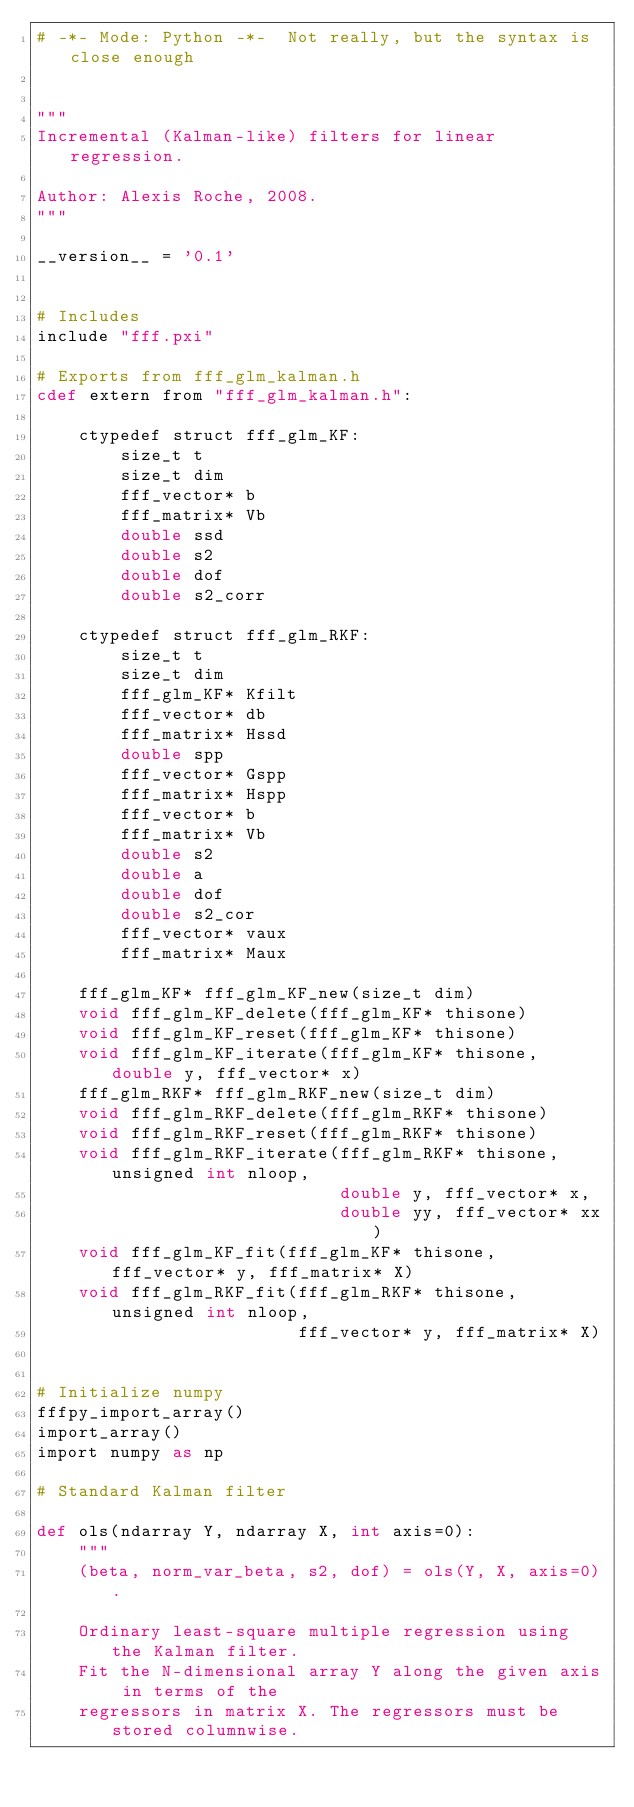Convert code to text. <code><loc_0><loc_0><loc_500><loc_500><_Cython_># -*- Mode: Python -*-  Not really, but the syntax is close enough


"""
Incremental (Kalman-like) filters for linear regression. 

Author: Alexis Roche, 2008.
"""

__version__ = '0.1'


# Includes
include "fff.pxi"

# Exports from fff_glm_kalman.h
cdef extern from "fff_glm_kalman.h":

    ctypedef struct fff_glm_KF:
        size_t t
        size_t dim
        fff_vector* b
        fff_matrix* Vb
        double ssd
        double s2
        double dof
        double s2_corr

    ctypedef struct fff_glm_RKF:
        size_t t
        size_t dim
        fff_glm_KF* Kfilt
        fff_vector* db
        fff_matrix* Hssd
        double spp
        fff_vector* Gspp
        fff_matrix* Hspp
        fff_vector* b
        fff_matrix* Vb
        double s2
        double a
        double dof
        double s2_cor
        fff_vector* vaux
        fff_matrix* Maux

    fff_glm_KF* fff_glm_KF_new(size_t dim)
    void fff_glm_KF_delete(fff_glm_KF* thisone)
    void fff_glm_KF_reset(fff_glm_KF* thisone)
    void fff_glm_KF_iterate(fff_glm_KF* thisone, double y, fff_vector* x)
    fff_glm_RKF* fff_glm_RKF_new(size_t dim)
    void fff_glm_RKF_delete(fff_glm_RKF* thisone)
    void fff_glm_RKF_reset(fff_glm_RKF* thisone)
    void fff_glm_RKF_iterate(fff_glm_RKF* thisone, unsigned int nloop, 
                             double y, fff_vector* x, 
                             double yy, fff_vector* xx)
    void fff_glm_KF_fit(fff_glm_KF* thisone, fff_vector* y, fff_matrix* X)
    void fff_glm_RKF_fit(fff_glm_RKF* thisone, unsigned int nloop, 
                         fff_vector* y, fff_matrix* X)


# Initialize numpy
fffpy_import_array()
import_array()
import numpy as np

# Standard Kalman filter

def ols(ndarray Y, ndarray X, int axis=0): 
    """
    (beta, norm_var_beta, s2, dof) = ols(Y, X, axis=0).

    Ordinary least-square multiple regression using the Kalman filter.
    Fit the N-dimensional array Y along the given axis in terms of the
    regressors in matrix X. The regressors must be stored columnwise.
</code> 